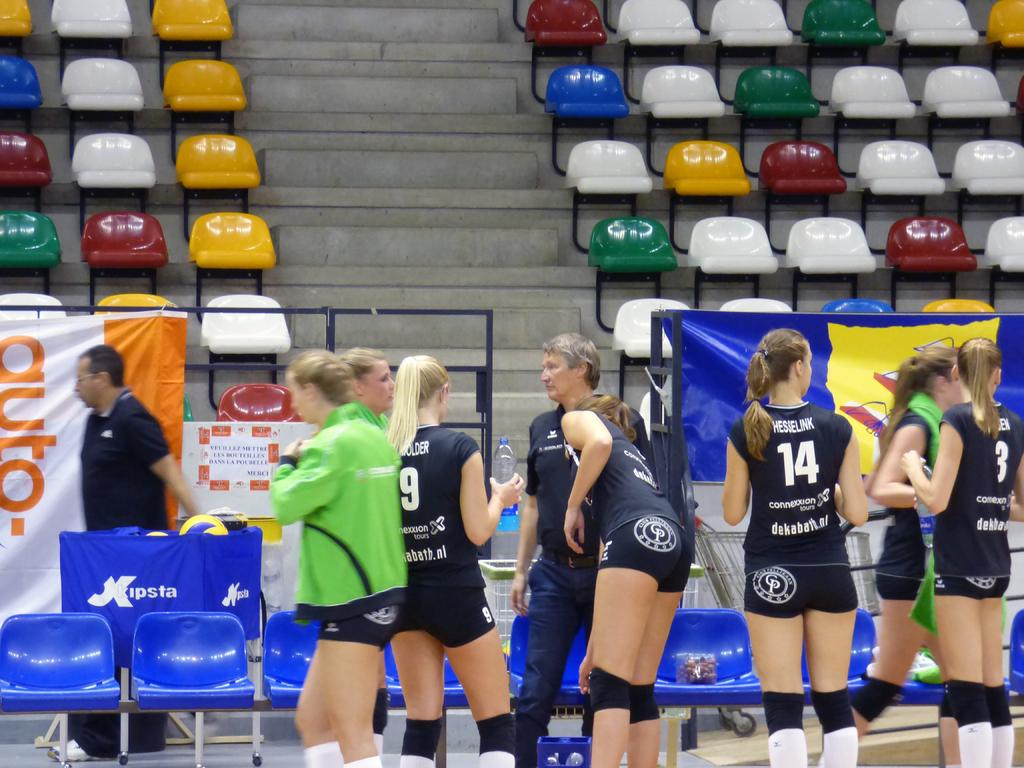What is happening in the foreground of the image? There is a group of people in the foreground of the image. What is the position of the people in relation to the ground? The people are on the ground. What can be seen in the background of the image? There are seats, a fence, boards, and a staircase in the background of the image. When was the image taken? The image was taken during the day. Where was the image taken? The image was taken on a pitch. What type of map is being used by the people in the image? There is no map present in the image. What is the source of pleasure for the people in the image? The image does not provide information about the people's source of pleasure. 